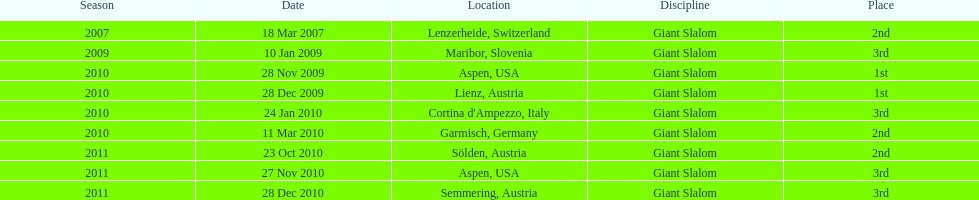What is the unique site in the us? Aspen. 